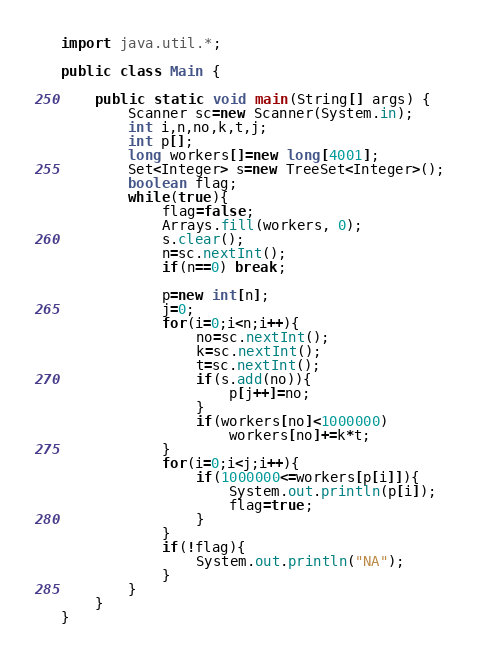Convert code to text. <code><loc_0><loc_0><loc_500><loc_500><_Java_>import java.util.*;

public class Main {

	public static void main(String[] args) {
		Scanner sc=new Scanner(System.in);
		int i,n,no,k,t,j;
		int p[];
		long workers[]=new long[4001];
		Set<Integer> s=new TreeSet<Integer>();
		boolean flag;
		while(true){
			flag=false;
			Arrays.fill(workers, 0);
			s.clear();
			n=sc.nextInt();
			if(n==0) break;

			p=new int[n];
			j=0;
			for(i=0;i<n;i++){
				no=sc.nextInt();
				k=sc.nextInt();
				t=sc.nextInt();
				if(s.add(no)){
					p[j++]=no;
				}
				if(workers[no]<1000000)
					workers[no]+=k*t;
			}
			for(i=0;i<j;i++){
				if(1000000<=workers[p[i]]){
					System.out.println(p[i]);
					flag=true;
				}
			}
			if(!flag){
				System.out.println("NA");
			}
		}
	}
}</code> 